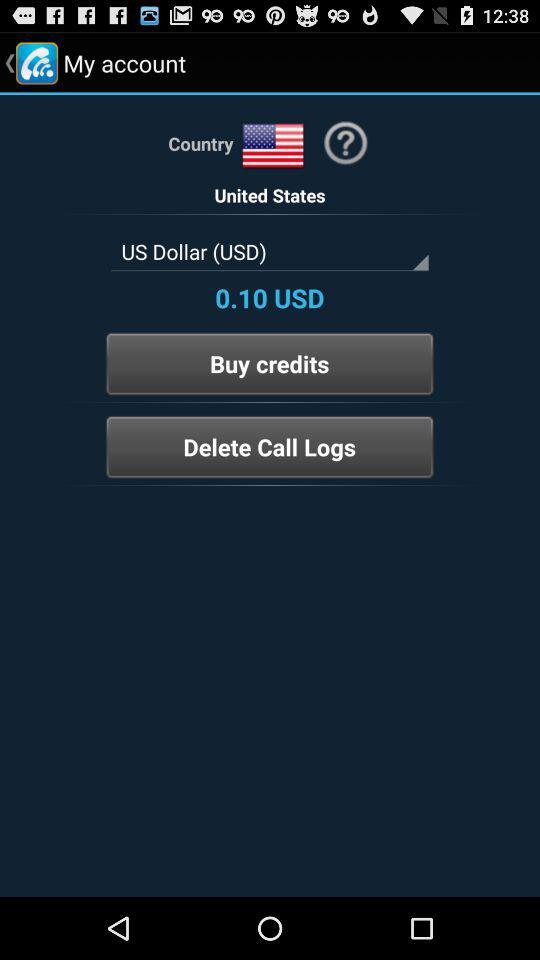What's the country? The country is the United States. 